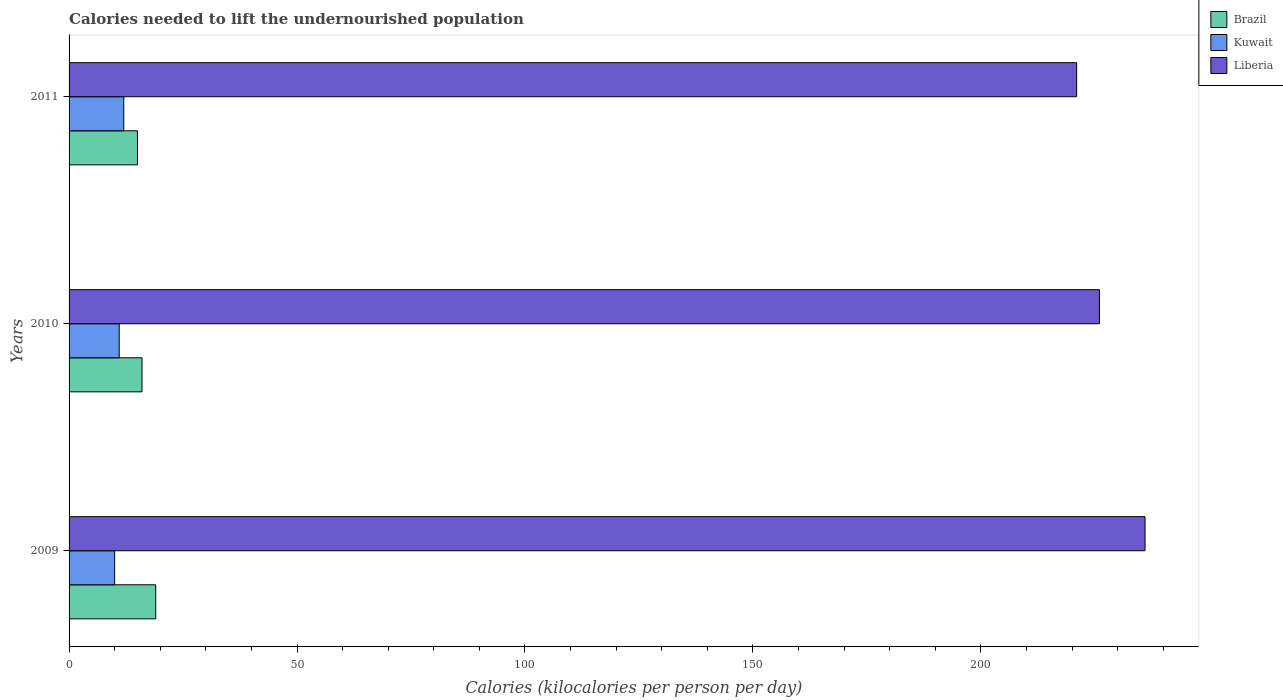How many groups of bars are there?
Ensure brevity in your answer.  3. What is the label of the 1st group of bars from the top?
Your answer should be very brief. 2011. In how many cases, is the number of bars for a given year not equal to the number of legend labels?
Give a very brief answer. 0. What is the total calories needed to lift the undernourished population in Liberia in 2011?
Provide a succinct answer. 221. Across all years, what is the maximum total calories needed to lift the undernourished population in Brazil?
Ensure brevity in your answer.  19. Across all years, what is the minimum total calories needed to lift the undernourished population in Brazil?
Your response must be concise. 15. In which year was the total calories needed to lift the undernourished population in Brazil maximum?
Your answer should be compact. 2009. In which year was the total calories needed to lift the undernourished population in Kuwait minimum?
Your response must be concise. 2009. What is the total total calories needed to lift the undernourished population in Kuwait in the graph?
Make the answer very short. 33. What is the difference between the total calories needed to lift the undernourished population in Liberia in 2009 and that in 2011?
Your response must be concise. 15. What is the difference between the total calories needed to lift the undernourished population in Liberia in 2010 and the total calories needed to lift the undernourished population in Brazil in 2009?
Your response must be concise. 207. What is the average total calories needed to lift the undernourished population in Liberia per year?
Your answer should be compact. 227.67. In the year 2009, what is the difference between the total calories needed to lift the undernourished population in Kuwait and total calories needed to lift the undernourished population in Brazil?
Make the answer very short. -9. In how many years, is the total calories needed to lift the undernourished population in Brazil greater than 30 kilocalories?
Make the answer very short. 0. What is the ratio of the total calories needed to lift the undernourished population in Kuwait in 2009 to that in 2010?
Your answer should be very brief. 0.91. Is the total calories needed to lift the undernourished population in Brazil in 2009 less than that in 2010?
Give a very brief answer. No. Is the difference between the total calories needed to lift the undernourished population in Kuwait in 2009 and 2011 greater than the difference between the total calories needed to lift the undernourished population in Brazil in 2009 and 2011?
Keep it short and to the point. No. What is the difference between the highest and the lowest total calories needed to lift the undernourished population in Brazil?
Offer a terse response. 4. In how many years, is the total calories needed to lift the undernourished population in Kuwait greater than the average total calories needed to lift the undernourished population in Kuwait taken over all years?
Provide a succinct answer. 1. Is the sum of the total calories needed to lift the undernourished population in Liberia in 2010 and 2011 greater than the maximum total calories needed to lift the undernourished population in Brazil across all years?
Your response must be concise. Yes. What does the 2nd bar from the top in 2010 represents?
Provide a succinct answer. Kuwait. What does the 1st bar from the bottom in 2011 represents?
Your answer should be very brief. Brazil. Is it the case that in every year, the sum of the total calories needed to lift the undernourished population in Brazil and total calories needed to lift the undernourished population in Kuwait is greater than the total calories needed to lift the undernourished population in Liberia?
Your response must be concise. No. How many bars are there?
Keep it short and to the point. 9. Are all the bars in the graph horizontal?
Your answer should be very brief. Yes. Does the graph contain any zero values?
Your answer should be compact. No. Does the graph contain grids?
Keep it short and to the point. No. How many legend labels are there?
Ensure brevity in your answer.  3. What is the title of the graph?
Make the answer very short. Calories needed to lift the undernourished population. Does "Micronesia" appear as one of the legend labels in the graph?
Make the answer very short. No. What is the label or title of the X-axis?
Your answer should be very brief. Calories (kilocalories per person per day). What is the label or title of the Y-axis?
Give a very brief answer. Years. What is the Calories (kilocalories per person per day) of Liberia in 2009?
Provide a succinct answer. 236. What is the Calories (kilocalories per person per day) in Kuwait in 2010?
Keep it short and to the point. 11. What is the Calories (kilocalories per person per day) in Liberia in 2010?
Give a very brief answer. 226. What is the Calories (kilocalories per person per day) of Liberia in 2011?
Your response must be concise. 221. Across all years, what is the maximum Calories (kilocalories per person per day) of Brazil?
Offer a very short reply. 19. Across all years, what is the maximum Calories (kilocalories per person per day) in Liberia?
Your answer should be compact. 236. Across all years, what is the minimum Calories (kilocalories per person per day) of Brazil?
Give a very brief answer. 15. Across all years, what is the minimum Calories (kilocalories per person per day) of Liberia?
Your response must be concise. 221. What is the total Calories (kilocalories per person per day) in Liberia in the graph?
Offer a very short reply. 683. What is the difference between the Calories (kilocalories per person per day) in Brazil in 2009 and that in 2010?
Ensure brevity in your answer.  3. What is the difference between the Calories (kilocalories per person per day) of Brazil in 2009 and that in 2011?
Provide a short and direct response. 4. What is the difference between the Calories (kilocalories per person per day) of Kuwait in 2009 and that in 2011?
Provide a succinct answer. -2. What is the difference between the Calories (kilocalories per person per day) in Liberia in 2009 and that in 2011?
Your answer should be very brief. 15. What is the difference between the Calories (kilocalories per person per day) of Kuwait in 2010 and that in 2011?
Ensure brevity in your answer.  -1. What is the difference between the Calories (kilocalories per person per day) of Brazil in 2009 and the Calories (kilocalories per person per day) of Liberia in 2010?
Ensure brevity in your answer.  -207. What is the difference between the Calories (kilocalories per person per day) in Kuwait in 2009 and the Calories (kilocalories per person per day) in Liberia in 2010?
Offer a very short reply. -216. What is the difference between the Calories (kilocalories per person per day) in Brazil in 2009 and the Calories (kilocalories per person per day) in Liberia in 2011?
Your response must be concise. -202. What is the difference between the Calories (kilocalories per person per day) of Kuwait in 2009 and the Calories (kilocalories per person per day) of Liberia in 2011?
Offer a very short reply. -211. What is the difference between the Calories (kilocalories per person per day) of Brazil in 2010 and the Calories (kilocalories per person per day) of Liberia in 2011?
Your answer should be compact. -205. What is the difference between the Calories (kilocalories per person per day) of Kuwait in 2010 and the Calories (kilocalories per person per day) of Liberia in 2011?
Your answer should be very brief. -210. What is the average Calories (kilocalories per person per day) in Brazil per year?
Your response must be concise. 16.67. What is the average Calories (kilocalories per person per day) of Liberia per year?
Your answer should be compact. 227.67. In the year 2009, what is the difference between the Calories (kilocalories per person per day) of Brazil and Calories (kilocalories per person per day) of Kuwait?
Provide a short and direct response. 9. In the year 2009, what is the difference between the Calories (kilocalories per person per day) in Brazil and Calories (kilocalories per person per day) in Liberia?
Give a very brief answer. -217. In the year 2009, what is the difference between the Calories (kilocalories per person per day) in Kuwait and Calories (kilocalories per person per day) in Liberia?
Provide a succinct answer. -226. In the year 2010, what is the difference between the Calories (kilocalories per person per day) in Brazil and Calories (kilocalories per person per day) in Liberia?
Give a very brief answer. -210. In the year 2010, what is the difference between the Calories (kilocalories per person per day) of Kuwait and Calories (kilocalories per person per day) of Liberia?
Your answer should be compact. -215. In the year 2011, what is the difference between the Calories (kilocalories per person per day) of Brazil and Calories (kilocalories per person per day) of Kuwait?
Provide a short and direct response. 3. In the year 2011, what is the difference between the Calories (kilocalories per person per day) of Brazil and Calories (kilocalories per person per day) of Liberia?
Your response must be concise. -206. In the year 2011, what is the difference between the Calories (kilocalories per person per day) of Kuwait and Calories (kilocalories per person per day) of Liberia?
Your response must be concise. -209. What is the ratio of the Calories (kilocalories per person per day) in Brazil in 2009 to that in 2010?
Your answer should be compact. 1.19. What is the ratio of the Calories (kilocalories per person per day) in Liberia in 2009 to that in 2010?
Your response must be concise. 1.04. What is the ratio of the Calories (kilocalories per person per day) of Brazil in 2009 to that in 2011?
Offer a very short reply. 1.27. What is the ratio of the Calories (kilocalories per person per day) of Liberia in 2009 to that in 2011?
Give a very brief answer. 1.07. What is the ratio of the Calories (kilocalories per person per day) of Brazil in 2010 to that in 2011?
Keep it short and to the point. 1.07. What is the ratio of the Calories (kilocalories per person per day) in Kuwait in 2010 to that in 2011?
Your answer should be very brief. 0.92. What is the ratio of the Calories (kilocalories per person per day) of Liberia in 2010 to that in 2011?
Provide a succinct answer. 1.02. What is the difference between the highest and the second highest Calories (kilocalories per person per day) of Liberia?
Your answer should be compact. 10. What is the difference between the highest and the lowest Calories (kilocalories per person per day) in Brazil?
Ensure brevity in your answer.  4. What is the difference between the highest and the lowest Calories (kilocalories per person per day) of Liberia?
Ensure brevity in your answer.  15. 